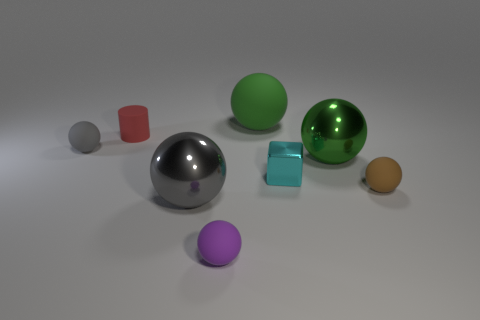What number of other things are the same color as the small shiny cube?
Offer a very short reply. 0. There is a red matte thing that is the same size as the brown sphere; what shape is it?
Keep it short and to the point. Cylinder. What number of big things are either matte objects or rubber blocks?
Provide a short and direct response. 1. Is there a ball that is right of the sphere behind the tiny matte thing that is to the left of the small red matte cylinder?
Provide a succinct answer. Yes. Are there any green balls of the same size as the green metallic object?
Provide a succinct answer. Yes. There is a brown ball that is the same size as the purple object; what is its material?
Keep it short and to the point. Rubber. Is the size of the gray matte ball the same as the matte cylinder behind the cube?
Your response must be concise. Yes. How many matte objects are either green balls or big red blocks?
Provide a short and direct response. 1. What number of other cyan things are the same shape as the cyan object?
Your response must be concise. 0. What material is the object that is the same color as the big rubber sphere?
Provide a succinct answer. Metal. 